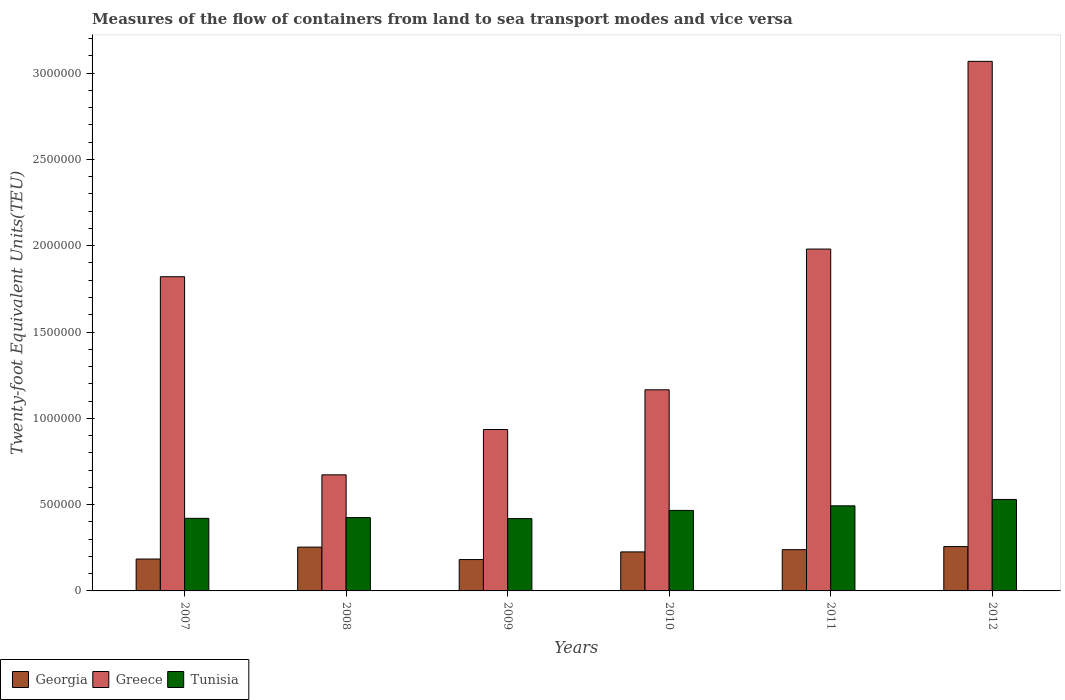How many different coloured bars are there?
Ensure brevity in your answer.  3. How many groups of bars are there?
Provide a short and direct response. 6. How many bars are there on the 5th tick from the right?
Make the answer very short. 3. What is the label of the 5th group of bars from the left?
Your answer should be very brief. 2011. In how many cases, is the number of bars for a given year not equal to the number of legend labels?
Provide a short and direct response. 0. What is the container port traffic in Tunisia in 2010?
Provide a succinct answer. 4.66e+05. Across all years, what is the maximum container port traffic in Greece?
Ensure brevity in your answer.  3.07e+06. Across all years, what is the minimum container port traffic in Greece?
Your answer should be compact. 6.73e+05. In which year was the container port traffic in Georgia maximum?
Provide a short and direct response. 2012. What is the total container port traffic in Tunisia in the graph?
Give a very brief answer. 2.75e+06. What is the difference between the container port traffic in Greece in 2009 and that in 2012?
Ensure brevity in your answer.  -2.13e+06. What is the difference between the container port traffic in Tunisia in 2011 and the container port traffic in Georgia in 2012?
Your response must be concise. 2.36e+05. What is the average container port traffic in Georgia per year?
Make the answer very short. 2.24e+05. In the year 2007, what is the difference between the container port traffic in Greece and container port traffic in Georgia?
Provide a succinct answer. 1.64e+06. What is the ratio of the container port traffic in Greece in 2008 to that in 2011?
Make the answer very short. 0.34. What is the difference between the highest and the second highest container port traffic in Tunisia?
Provide a succinct answer. 3.70e+04. What is the difference between the highest and the lowest container port traffic in Georgia?
Make the answer very short. 7.53e+04. What does the 1st bar from the left in 2010 represents?
Offer a terse response. Georgia. What does the 2nd bar from the right in 2012 represents?
Your answer should be compact. Greece. Is it the case that in every year, the sum of the container port traffic in Tunisia and container port traffic in Georgia is greater than the container port traffic in Greece?
Offer a terse response. No. How many years are there in the graph?
Offer a very short reply. 6. What is the difference between two consecutive major ticks on the Y-axis?
Provide a short and direct response. 5.00e+05. Are the values on the major ticks of Y-axis written in scientific E-notation?
Offer a very short reply. No. Does the graph contain any zero values?
Give a very brief answer. No. How are the legend labels stacked?
Ensure brevity in your answer.  Horizontal. What is the title of the graph?
Your answer should be compact. Measures of the flow of containers from land to sea transport modes and vice versa. What is the label or title of the X-axis?
Keep it short and to the point. Years. What is the label or title of the Y-axis?
Make the answer very short. Twenty-foot Equivalent Units(TEU). What is the Twenty-foot Equivalent Units(TEU) of Georgia in 2007?
Your answer should be very brief. 1.85e+05. What is the Twenty-foot Equivalent Units(TEU) in Greece in 2007?
Ensure brevity in your answer.  1.82e+06. What is the Twenty-foot Equivalent Units(TEU) of Tunisia in 2007?
Ensure brevity in your answer.  4.21e+05. What is the Twenty-foot Equivalent Units(TEU) of Georgia in 2008?
Your response must be concise. 2.54e+05. What is the Twenty-foot Equivalent Units(TEU) in Greece in 2008?
Ensure brevity in your answer.  6.73e+05. What is the Twenty-foot Equivalent Units(TEU) in Tunisia in 2008?
Make the answer very short. 4.25e+05. What is the Twenty-foot Equivalent Units(TEU) in Georgia in 2009?
Provide a short and direct response. 1.82e+05. What is the Twenty-foot Equivalent Units(TEU) of Greece in 2009?
Ensure brevity in your answer.  9.35e+05. What is the Twenty-foot Equivalent Units(TEU) of Tunisia in 2009?
Make the answer very short. 4.19e+05. What is the Twenty-foot Equivalent Units(TEU) in Georgia in 2010?
Your answer should be very brief. 2.26e+05. What is the Twenty-foot Equivalent Units(TEU) of Greece in 2010?
Keep it short and to the point. 1.17e+06. What is the Twenty-foot Equivalent Units(TEU) of Tunisia in 2010?
Your answer should be compact. 4.66e+05. What is the Twenty-foot Equivalent Units(TEU) in Georgia in 2011?
Give a very brief answer. 2.39e+05. What is the Twenty-foot Equivalent Units(TEU) of Greece in 2011?
Offer a very short reply. 1.98e+06. What is the Twenty-foot Equivalent Units(TEU) in Tunisia in 2011?
Provide a short and direct response. 4.93e+05. What is the Twenty-foot Equivalent Units(TEU) of Georgia in 2012?
Your response must be concise. 2.57e+05. What is the Twenty-foot Equivalent Units(TEU) of Greece in 2012?
Make the answer very short. 3.07e+06. What is the Twenty-foot Equivalent Units(TEU) of Tunisia in 2012?
Your answer should be compact. 5.30e+05. Across all years, what is the maximum Twenty-foot Equivalent Units(TEU) in Georgia?
Keep it short and to the point. 2.57e+05. Across all years, what is the maximum Twenty-foot Equivalent Units(TEU) in Greece?
Offer a very short reply. 3.07e+06. Across all years, what is the maximum Twenty-foot Equivalent Units(TEU) in Tunisia?
Your response must be concise. 5.30e+05. Across all years, what is the minimum Twenty-foot Equivalent Units(TEU) of Georgia?
Keep it short and to the point. 1.82e+05. Across all years, what is the minimum Twenty-foot Equivalent Units(TEU) in Greece?
Provide a succinct answer. 6.73e+05. Across all years, what is the minimum Twenty-foot Equivalent Units(TEU) in Tunisia?
Provide a short and direct response. 4.19e+05. What is the total Twenty-foot Equivalent Units(TEU) of Georgia in the graph?
Your answer should be very brief. 1.34e+06. What is the total Twenty-foot Equivalent Units(TEU) in Greece in the graph?
Your answer should be compact. 9.64e+06. What is the total Twenty-foot Equivalent Units(TEU) in Tunisia in the graph?
Make the answer very short. 2.75e+06. What is the difference between the Twenty-foot Equivalent Units(TEU) of Georgia in 2007 and that in 2008?
Ensure brevity in your answer.  -6.90e+04. What is the difference between the Twenty-foot Equivalent Units(TEU) in Greece in 2007 and that in 2008?
Ensure brevity in your answer.  1.15e+06. What is the difference between the Twenty-foot Equivalent Units(TEU) in Tunisia in 2007 and that in 2008?
Give a very brief answer. -4279. What is the difference between the Twenty-foot Equivalent Units(TEU) of Georgia in 2007 and that in 2009?
Offer a terse response. 3179. What is the difference between the Twenty-foot Equivalent Units(TEU) in Greece in 2007 and that in 2009?
Your answer should be compact. 8.85e+05. What is the difference between the Twenty-foot Equivalent Units(TEU) of Tunisia in 2007 and that in 2009?
Give a very brief answer. 1617.13. What is the difference between the Twenty-foot Equivalent Units(TEU) in Georgia in 2007 and that in 2010?
Provide a short and direct response. -4.13e+04. What is the difference between the Twenty-foot Equivalent Units(TEU) in Greece in 2007 and that in 2010?
Offer a very short reply. 6.55e+05. What is the difference between the Twenty-foot Equivalent Units(TEU) of Tunisia in 2007 and that in 2010?
Your response must be concise. -4.59e+04. What is the difference between the Twenty-foot Equivalent Units(TEU) in Georgia in 2007 and that in 2011?
Make the answer very short. -5.42e+04. What is the difference between the Twenty-foot Equivalent Units(TEU) in Greece in 2007 and that in 2011?
Offer a terse response. -1.60e+05. What is the difference between the Twenty-foot Equivalent Units(TEU) in Tunisia in 2007 and that in 2011?
Your answer should be compact. -7.25e+04. What is the difference between the Twenty-foot Equivalent Units(TEU) of Georgia in 2007 and that in 2012?
Offer a very short reply. -7.21e+04. What is the difference between the Twenty-foot Equivalent Units(TEU) of Greece in 2007 and that in 2012?
Ensure brevity in your answer.  -1.25e+06. What is the difference between the Twenty-foot Equivalent Units(TEU) of Tunisia in 2007 and that in 2012?
Your answer should be very brief. -1.09e+05. What is the difference between the Twenty-foot Equivalent Units(TEU) in Georgia in 2008 and that in 2009?
Your response must be concise. 7.22e+04. What is the difference between the Twenty-foot Equivalent Units(TEU) in Greece in 2008 and that in 2009?
Offer a terse response. -2.63e+05. What is the difference between the Twenty-foot Equivalent Units(TEU) in Tunisia in 2008 and that in 2009?
Offer a very short reply. 5896.13. What is the difference between the Twenty-foot Equivalent Units(TEU) in Georgia in 2008 and that in 2010?
Give a very brief answer. 2.77e+04. What is the difference between the Twenty-foot Equivalent Units(TEU) in Greece in 2008 and that in 2010?
Offer a terse response. -4.93e+05. What is the difference between the Twenty-foot Equivalent Units(TEU) of Tunisia in 2008 and that in 2010?
Your answer should be very brief. -4.16e+04. What is the difference between the Twenty-foot Equivalent Units(TEU) of Georgia in 2008 and that in 2011?
Provide a succinct answer. 1.48e+04. What is the difference between the Twenty-foot Equivalent Units(TEU) in Greece in 2008 and that in 2011?
Provide a succinct answer. -1.31e+06. What is the difference between the Twenty-foot Equivalent Units(TEU) of Tunisia in 2008 and that in 2011?
Your response must be concise. -6.82e+04. What is the difference between the Twenty-foot Equivalent Units(TEU) of Georgia in 2008 and that in 2012?
Your answer should be compact. -3117.82. What is the difference between the Twenty-foot Equivalent Units(TEU) of Greece in 2008 and that in 2012?
Make the answer very short. -2.40e+06. What is the difference between the Twenty-foot Equivalent Units(TEU) in Tunisia in 2008 and that in 2012?
Provide a short and direct response. -1.05e+05. What is the difference between the Twenty-foot Equivalent Units(TEU) of Georgia in 2009 and that in 2010?
Make the answer very short. -4.45e+04. What is the difference between the Twenty-foot Equivalent Units(TEU) of Greece in 2009 and that in 2010?
Your response must be concise. -2.30e+05. What is the difference between the Twenty-foot Equivalent Units(TEU) in Tunisia in 2009 and that in 2010?
Your response must be concise. -4.75e+04. What is the difference between the Twenty-foot Equivalent Units(TEU) of Georgia in 2009 and that in 2011?
Keep it short and to the point. -5.74e+04. What is the difference between the Twenty-foot Equivalent Units(TEU) of Greece in 2009 and that in 2011?
Your response must be concise. -1.05e+06. What is the difference between the Twenty-foot Equivalent Units(TEU) in Tunisia in 2009 and that in 2011?
Your answer should be very brief. -7.41e+04. What is the difference between the Twenty-foot Equivalent Units(TEU) in Georgia in 2009 and that in 2012?
Offer a very short reply. -7.53e+04. What is the difference between the Twenty-foot Equivalent Units(TEU) in Greece in 2009 and that in 2012?
Your response must be concise. -2.13e+06. What is the difference between the Twenty-foot Equivalent Units(TEU) of Tunisia in 2009 and that in 2012?
Provide a succinct answer. -1.11e+05. What is the difference between the Twenty-foot Equivalent Units(TEU) of Georgia in 2010 and that in 2011?
Ensure brevity in your answer.  -1.29e+04. What is the difference between the Twenty-foot Equivalent Units(TEU) in Greece in 2010 and that in 2011?
Give a very brief answer. -8.15e+05. What is the difference between the Twenty-foot Equivalent Units(TEU) in Tunisia in 2010 and that in 2011?
Offer a very short reply. -2.66e+04. What is the difference between the Twenty-foot Equivalent Units(TEU) in Georgia in 2010 and that in 2012?
Make the answer very short. -3.08e+04. What is the difference between the Twenty-foot Equivalent Units(TEU) of Greece in 2010 and that in 2012?
Your answer should be compact. -1.90e+06. What is the difference between the Twenty-foot Equivalent Units(TEU) of Tunisia in 2010 and that in 2012?
Give a very brief answer. -6.36e+04. What is the difference between the Twenty-foot Equivalent Units(TEU) in Georgia in 2011 and that in 2012?
Offer a very short reply. -1.79e+04. What is the difference between the Twenty-foot Equivalent Units(TEU) of Greece in 2011 and that in 2012?
Offer a terse response. -1.09e+06. What is the difference between the Twenty-foot Equivalent Units(TEU) of Tunisia in 2011 and that in 2012?
Offer a very short reply. -3.70e+04. What is the difference between the Twenty-foot Equivalent Units(TEU) in Georgia in 2007 and the Twenty-foot Equivalent Units(TEU) in Greece in 2008?
Offer a very short reply. -4.88e+05. What is the difference between the Twenty-foot Equivalent Units(TEU) of Georgia in 2007 and the Twenty-foot Equivalent Units(TEU) of Tunisia in 2008?
Offer a very short reply. -2.40e+05. What is the difference between the Twenty-foot Equivalent Units(TEU) of Greece in 2007 and the Twenty-foot Equivalent Units(TEU) of Tunisia in 2008?
Offer a terse response. 1.40e+06. What is the difference between the Twenty-foot Equivalent Units(TEU) in Georgia in 2007 and the Twenty-foot Equivalent Units(TEU) in Greece in 2009?
Make the answer very short. -7.50e+05. What is the difference between the Twenty-foot Equivalent Units(TEU) of Georgia in 2007 and the Twenty-foot Equivalent Units(TEU) of Tunisia in 2009?
Provide a short and direct response. -2.34e+05. What is the difference between the Twenty-foot Equivalent Units(TEU) of Greece in 2007 and the Twenty-foot Equivalent Units(TEU) of Tunisia in 2009?
Provide a succinct answer. 1.40e+06. What is the difference between the Twenty-foot Equivalent Units(TEU) in Georgia in 2007 and the Twenty-foot Equivalent Units(TEU) in Greece in 2010?
Provide a short and direct response. -9.80e+05. What is the difference between the Twenty-foot Equivalent Units(TEU) of Georgia in 2007 and the Twenty-foot Equivalent Units(TEU) of Tunisia in 2010?
Your response must be concise. -2.82e+05. What is the difference between the Twenty-foot Equivalent Units(TEU) in Greece in 2007 and the Twenty-foot Equivalent Units(TEU) in Tunisia in 2010?
Make the answer very short. 1.35e+06. What is the difference between the Twenty-foot Equivalent Units(TEU) of Georgia in 2007 and the Twenty-foot Equivalent Units(TEU) of Greece in 2011?
Provide a short and direct response. -1.80e+06. What is the difference between the Twenty-foot Equivalent Units(TEU) in Georgia in 2007 and the Twenty-foot Equivalent Units(TEU) in Tunisia in 2011?
Your answer should be compact. -3.08e+05. What is the difference between the Twenty-foot Equivalent Units(TEU) in Greece in 2007 and the Twenty-foot Equivalent Units(TEU) in Tunisia in 2011?
Your answer should be compact. 1.33e+06. What is the difference between the Twenty-foot Equivalent Units(TEU) of Georgia in 2007 and the Twenty-foot Equivalent Units(TEU) of Greece in 2012?
Your answer should be very brief. -2.88e+06. What is the difference between the Twenty-foot Equivalent Units(TEU) of Georgia in 2007 and the Twenty-foot Equivalent Units(TEU) of Tunisia in 2012?
Your response must be concise. -3.45e+05. What is the difference between the Twenty-foot Equivalent Units(TEU) in Greece in 2007 and the Twenty-foot Equivalent Units(TEU) in Tunisia in 2012?
Your answer should be compact. 1.29e+06. What is the difference between the Twenty-foot Equivalent Units(TEU) in Georgia in 2008 and the Twenty-foot Equivalent Units(TEU) in Greece in 2009?
Make the answer very short. -6.81e+05. What is the difference between the Twenty-foot Equivalent Units(TEU) in Georgia in 2008 and the Twenty-foot Equivalent Units(TEU) in Tunisia in 2009?
Your response must be concise. -1.65e+05. What is the difference between the Twenty-foot Equivalent Units(TEU) of Greece in 2008 and the Twenty-foot Equivalent Units(TEU) of Tunisia in 2009?
Offer a very short reply. 2.54e+05. What is the difference between the Twenty-foot Equivalent Units(TEU) of Georgia in 2008 and the Twenty-foot Equivalent Units(TEU) of Greece in 2010?
Offer a terse response. -9.11e+05. What is the difference between the Twenty-foot Equivalent Units(TEU) of Georgia in 2008 and the Twenty-foot Equivalent Units(TEU) of Tunisia in 2010?
Your answer should be very brief. -2.13e+05. What is the difference between the Twenty-foot Equivalent Units(TEU) in Greece in 2008 and the Twenty-foot Equivalent Units(TEU) in Tunisia in 2010?
Offer a very short reply. 2.06e+05. What is the difference between the Twenty-foot Equivalent Units(TEU) in Georgia in 2008 and the Twenty-foot Equivalent Units(TEU) in Greece in 2011?
Make the answer very short. -1.73e+06. What is the difference between the Twenty-foot Equivalent Units(TEU) in Georgia in 2008 and the Twenty-foot Equivalent Units(TEU) in Tunisia in 2011?
Provide a succinct answer. -2.39e+05. What is the difference between the Twenty-foot Equivalent Units(TEU) in Greece in 2008 and the Twenty-foot Equivalent Units(TEU) in Tunisia in 2011?
Your answer should be very brief. 1.80e+05. What is the difference between the Twenty-foot Equivalent Units(TEU) of Georgia in 2008 and the Twenty-foot Equivalent Units(TEU) of Greece in 2012?
Ensure brevity in your answer.  -2.81e+06. What is the difference between the Twenty-foot Equivalent Units(TEU) in Georgia in 2008 and the Twenty-foot Equivalent Units(TEU) in Tunisia in 2012?
Make the answer very short. -2.76e+05. What is the difference between the Twenty-foot Equivalent Units(TEU) in Greece in 2008 and the Twenty-foot Equivalent Units(TEU) in Tunisia in 2012?
Offer a very short reply. 1.43e+05. What is the difference between the Twenty-foot Equivalent Units(TEU) in Georgia in 2009 and the Twenty-foot Equivalent Units(TEU) in Greece in 2010?
Provide a succinct answer. -9.84e+05. What is the difference between the Twenty-foot Equivalent Units(TEU) of Georgia in 2009 and the Twenty-foot Equivalent Units(TEU) of Tunisia in 2010?
Offer a terse response. -2.85e+05. What is the difference between the Twenty-foot Equivalent Units(TEU) in Greece in 2009 and the Twenty-foot Equivalent Units(TEU) in Tunisia in 2010?
Your answer should be very brief. 4.69e+05. What is the difference between the Twenty-foot Equivalent Units(TEU) of Georgia in 2009 and the Twenty-foot Equivalent Units(TEU) of Greece in 2011?
Your answer should be compact. -1.80e+06. What is the difference between the Twenty-foot Equivalent Units(TEU) in Georgia in 2009 and the Twenty-foot Equivalent Units(TEU) in Tunisia in 2011?
Provide a short and direct response. -3.11e+05. What is the difference between the Twenty-foot Equivalent Units(TEU) in Greece in 2009 and the Twenty-foot Equivalent Units(TEU) in Tunisia in 2011?
Your response must be concise. 4.42e+05. What is the difference between the Twenty-foot Equivalent Units(TEU) in Georgia in 2009 and the Twenty-foot Equivalent Units(TEU) in Greece in 2012?
Ensure brevity in your answer.  -2.89e+06. What is the difference between the Twenty-foot Equivalent Units(TEU) of Georgia in 2009 and the Twenty-foot Equivalent Units(TEU) of Tunisia in 2012?
Your response must be concise. -3.48e+05. What is the difference between the Twenty-foot Equivalent Units(TEU) in Greece in 2009 and the Twenty-foot Equivalent Units(TEU) in Tunisia in 2012?
Your answer should be very brief. 4.05e+05. What is the difference between the Twenty-foot Equivalent Units(TEU) in Georgia in 2010 and the Twenty-foot Equivalent Units(TEU) in Greece in 2011?
Offer a terse response. -1.75e+06. What is the difference between the Twenty-foot Equivalent Units(TEU) in Georgia in 2010 and the Twenty-foot Equivalent Units(TEU) in Tunisia in 2011?
Provide a short and direct response. -2.67e+05. What is the difference between the Twenty-foot Equivalent Units(TEU) in Greece in 2010 and the Twenty-foot Equivalent Units(TEU) in Tunisia in 2011?
Your answer should be compact. 6.72e+05. What is the difference between the Twenty-foot Equivalent Units(TEU) in Georgia in 2010 and the Twenty-foot Equivalent Units(TEU) in Greece in 2012?
Provide a short and direct response. -2.84e+06. What is the difference between the Twenty-foot Equivalent Units(TEU) in Georgia in 2010 and the Twenty-foot Equivalent Units(TEU) in Tunisia in 2012?
Provide a succinct answer. -3.04e+05. What is the difference between the Twenty-foot Equivalent Units(TEU) of Greece in 2010 and the Twenty-foot Equivalent Units(TEU) of Tunisia in 2012?
Give a very brief answer. 6.35e+05. What is the difference between the Twenty-foot Equivalent Units(TEU) in Georgia in 2011 and the Twenty-foot Equivalent Units(TEU) in Greece in 2012?
Offer a terse response. -2.83e+06. What is the difference between the Twenty-foot Equivalent Units(TEU) of Georgia in 2011 and the Twenty-foot Equivalent Units(TEU) of Tunisia in 2012?
Give a very brief answer. -2.91e+05. What is the difference between the Twenty-foot Equivalent Units(TEU) of Greece in 2011 and the Twenty-foot Equivalent Units(TEU) of Tunisia in 2012?
Your answer should be compact. 1.45e+06. What is the average Twenty-foot Equivalent Units(TEU) in Georgia per year?
Your answer should be compact. 2.24e+05. What is the average Twenty-foot Equivalent Units(TEU) of Greece per year?
Offer a terse response. 1.61e+06. What is the average Twenty-foot Equivalent Units(TEU) of Tunisia per year?
Provide a short and direct response. 4.59e+05. In the year 2007, what is the difference between the Twenty-foot Equivalent Units(TEU) of Georgia and Twenty-foot Equivalent Units(TEU) of Greece?
Your answer should be very brief. -1.64e+06. In the year 2007, what is the difference between the Twenty-foot Equivalent Units(TEU) in Georgia and Twenty-foot Equivalent Units(TEU) in Tunisia?
Provide a succinct answer. -2.36e+05. In the year 2007, what is the difference between the Twenty-foot Equivalent Units(TEU) in Greece and Twenty-foot Equivalent Units(TEU) in Tunisia?
Your answer should be very brief. 1.40e+06. In the year 2008, what is the difference between the Twenty-foot Equivalent Units(TEU) in Georgia and Twenty-foot Equivalent Units(TEU) in Greece?
Make the answer very short. -4.19e+05. In the year 2008, what is the difference between the Twenty-foot Equivalent Units(TEU) in Georgia and Twenty-foot Equivalent Units(TEU) in Tunisia?
Your answer should be compact. -1.71e+05. In the year 2008, what is the difference between the Twenty-foot Equivalent Units(TEU) of Greece and Twenty-foot Equivalent Units(TEU) of Tunisia?
Give a very brief answer. 2.48e+05. In the year 2009, what is the difference between the Twenty-foot Equivalent Units(TEU) in Georgia and Twenty-foot Equivalent Units(TEU) in Greece?
Your response must be concise. -7.53e+05. In the year 2009, what is the difference between the Twenty-foot Equivalent Units(TEU) in Georgia and Twenty-foot Equivalent Units(TEU) in Tunisia?
Your answer should be very brief. -2.37e+05. In the year 2009, what is the difference between the Twenty-foot Equivalent Units(TEU) of Greece and Twenty-foot Equivalent Units(TEU) of Tunisia?
Ensure brevity in your answer.  5.16e+05. In the year 2010, what is the difference between the Twenty-foot Equivalent Units(TEU) in Georgia and Twenty-foot Equivalent Units(TEU) in Greece?
Offer a very short reply. -9.39e+05. In the year 2010, what is the difference between the Twenty-foot Equivalent Units(TEU) of Georgia and Twenty-foot Equivalent Units(TEU) of Tunisia?
Make the answer very short. -2.40e+05. In the year 2010, what is the difference between the Twenty-foot Equivalent Units(TEU) in Greece and Twenty-foot Equivalent Units(TEU) in Tunisia?
Your response must be concise. 6.99e+05. In the year 2011, what is the difference between the Twenty-foot Equivalent Units(TEU) of Georgia and Twenty-foot Equivalent Units(TEU) of Greece?
Your answer should be compact. -1.74e+06. In the year 2011, what is the difference between the Twenty-foot Equivalent Units(TEU) in Georgia and Twenty-foot Equivalent Units(TEU) in Tunisia?
Your response must be concise. -2.54e+05. In the year 2011, what is the difference between the Twenty-foot Equivalent Units(TEU) of Greece and Twenty-foot Equivalent Units(TEU) of Tunisia?
Give a very brief answer. 1.49e+06. In the year 2012, what is the difference between the Twenty-foot Equivalent Units(TEU) in Georgia and Twenty-foot Equivalent Units(TEU) in Greece?
Give a very brief answer. -2.81e+06. In the year 2012, what is the difference between the Twenty-foot Equivalent Units(TEU) in Georgia and Twenty-foot Equivalent Units(TEU) in Tunisia?
Your response must be concise. -2.73e+05. In the year 2012, what is the difference between the Twenty-foot Equivalent Units(TEU) of Greece and Twenty-foot Equivalent Units(TEU) of Tunisia?
Provide a short and direct response. 2.54e+06. What is the ratio of the Twenty-foot Equivalent Units(TEU) of Georgia in 2007 to that in 2008?
Offer a very short reply. 0.73. What is the ratio of the Twenty-foot Equivalent Units(TEU) in Greece in 2007 to that in 2008?
Your answer should be compact. 2.71. What is the ratio of the Twenty-foot Equivalent Units(TEU) in Georgia in 2007 to that in 2009?
Ensure brevity in your answer.  1.02. What is the ratio of the Twenty-foot Equivalent Units(TEU) in Greece in 2007 to that in 2009?
Ensure brevity in your answer.  1.95. What is the ratio of the Twenty-foot Equivalent Units(TEU) of Tunisia in 2007 to that in 2009?
Your response must be concise. 1. What is the ratio of the Twenty-foot Equivalent Units(TEU) in Georgia in 2007 to that in 2010?
Your answer should be very brief. 0.82. What is the ratio of the Twenty-foot Equivalent Units(TEU) of Greece in 2007 to that in 2010?
Your answer should be very brief. 1.56. What is the ratio of the Twenty-foot Equivalent Units(TEU) in Tunisia in 2007 to that in 2010?
Provide a short and direct response. 0.9. What is the ratio of the Twenty-foot Equivalent Units(TEU) of Georgia in 2007 to that in 2011?
Provide a succinct answer. 0.77. What is the ratio of the Twenty-foot Equivalent Units(TEU) in Greece in 2007 to that in 2011?
Your response must be concise. 0.92. What is the ratio of the Twenty-foot Equivalent Units(TEU) of Tunisia in 2007 to that in 2011?
Your response must be concise. 0.85. What is the ratio of the Twenty-foot Equivalent Units(TEU) of Georgia in 2007 to that in 2012?
Your answer should be compact. 0.72. What is the ratio of the Twenty-foot Equivalent Units(TEU) in Greece in 2007 to that in 2012?
Your response must be concise. 0.59. What is the ratio of the Twenty-foot Equivalent Units(TEU) in Tunisia in 2007 to that in 2012?
Provide a succinct answer. 0.79. What is the ratio of the Twenty-foot Equivalent Units(TEU) in Georgia in 2008 to that in 2009?
Make the answer very short. 1.4. What is the ratio of the Twenty-foot Equivalent Units(TEU) in Greece in 2008 to that in 2009?
Ensure brevity in your answer.  0.72. What is the ratio of the Twenty-foot Equivalent Units(TEU) of Tunisia in 2008 to that in 2009?
Ensure brevity in your answer.  1.01. What is the ratio of the Twenty-foot Equivalent Units(TEU) in Georgia in 2008 to that in 2010?
Keep it short and to the point. 1.12. What is the ratio of the Twenty-foot Equivalent Units(TEU) of Greece in 2008 to that in 2010?
Make the answer very short. 0.58. What is the ratio of the Twenty-foot Equivalent Units(TEU) of Tunisia in 2008 to that in 2010?
Offer a very short reply. 0.91. What is the ratio of the Twenty-foot Equivalent Units(TEU) in Georgia in 2008 to that in 2011?
Give a very brief answer. 1.06. What is the ratio of the Twenty-foot Equivalent Units(TEU) in Greece in 2008 to that in 2011?
Give a very brief answer. 0.34. What is the ratio of the Twenty-foot Equivalent Units(TEU) in Tunisia in 2008 to that in 2011?
Ensure brevity in your answer.  0.86. What is the ratio of the Twenty-foot Equivalent Units(TEU) in Georgia in 2008 to that in 2012?
Keep it short and to the point. 0.99. What is the ratio of the Twenty-foot Equivalent Units(TEU) of Greece in 2008 to that in 2012?
Offer a very short reply. 0.22. What is the ratio of the Twenty-foot Equivalent Units(TEU) in Tunisia in 2008 to that in 2012?
Provide a short and direct response. 0.8. What is the ratio of the Twenty-foot Equivalent Units(TEU) of Georgia in 2009 to that in 2010?
Offer a very short reply. 0.8. What is the ratio of the Twenty-foot Equivalent Units(TEU) of Greece in 2009 to that in 2010?
Offer a very short reply. 0.8. What is the ratio of the Twenty-foot Equivalent Units(TEU) in Tunisia in 2009 to that in 2010?
Your response must be concise. 0.9. What is the ratio of the Twenty-foot Equivalent Units(TEU) in Georgia in 2009 to that in 2011?
Provide a succinct answer. 0.76. What is the ratio of the Twenty-foot Equivalent Units(TEU) of Greece in 2009 to that in 2011?
Make the answer very short. 0.47. What is the ratio of the Twenty-foot Equivalent Units(TEU) in Tunisia in 2009 to that in 2011?
Give a very brief answer. 0.85. What is the ratio of the Twenty-foot Equivalent Units(TEU) of Georgia in 2009 to that in 2012?
Provide a short and direct response. 0.71. What is the ratio of the Twenty-foot Equivalent Units(TEU) of Greece in 2009 to that in 2012?
Make the answer very short. 0.3. What is the ratio of the Twenty-foot Equivalent Units(TEU) in Tunisia in 2009 to that in 2012?
Offer a terse response. 0.79. What is the ratio of the Twenty-foot Equivalent Units(TEU) of Georgia in 2010 to that in 2011?
Provide a succinct answer. 0.95. What is the ratio of the Twenty-foot Equivalent Units(TEU) of Greece in 2010 to that in 2011?
Your response must be concise. 0.59. What is the ratio of the Twenty-foot Equivalent Units(TEU) of Tunisia in 2010 to that in 2011?
Your response must be concise. 0.95. What is the ratio of the Twenty-foot Equivalent Units(TEU) of Georgia in 2010 to that in 2012?
Provide a succinct answer. 0.88. What is the ratio of the Twenty-foot Equivalent Units(TEU) of Greece in 2010 to that in 2012?
Provide a short and direct response. 0.38. What is the ratio of the Twenty-foot Equivalent Units(TEU) in Tunisia in 2010 to that in 2012?
Give a very brief answer. 0.88. What is the ratio of the Twenty-foot Equivalent Units(TEU) in Georgia in 2011 to that in 2012?
Offer a very short reply. 0.93. What is the ratio of the Twenty-foot Equivalent Units(TEU) of Greece in 2011 to that in 2012?
Give a very brief answer. 0.65. What is the ratio of the Twenty-foot Equivalent Units(TEU) in Tunisia in 2011 to that in 2012?
Ensure brevity in your answer.  0.93. What is the difference between the highest and the second highest Twenty-foot Equivalent Units(TEU) of Georgia?
Provide a short and direct response. 3117.82. What is the difference between the highest and the second highest Twenty-foot Equivalent Units(TEU) of Greece?
Offer a very short reply. 1.09e+06. What is the difference between the highest and the second highest Twenty-foot Equivalent Units(TEU) of Tunisia?
Give a very brief answer. 3.70e+04. What is the difference between the highest and the lowest Twenty-foot Equivalent Units(TEU) in Georgia?
Your response must be concise. 7.53e+04. What is the difference between the highest and the lowest Twenty-foot Equivalent Units(TEU) of Greece?
Your response must be concise. 2.40e+06. What is the difference between the highest and the lowest Twenty-foot Equivalent Units(TEU) of Tunisia?
Ensure brevity in your answer.  1.11e+05. 